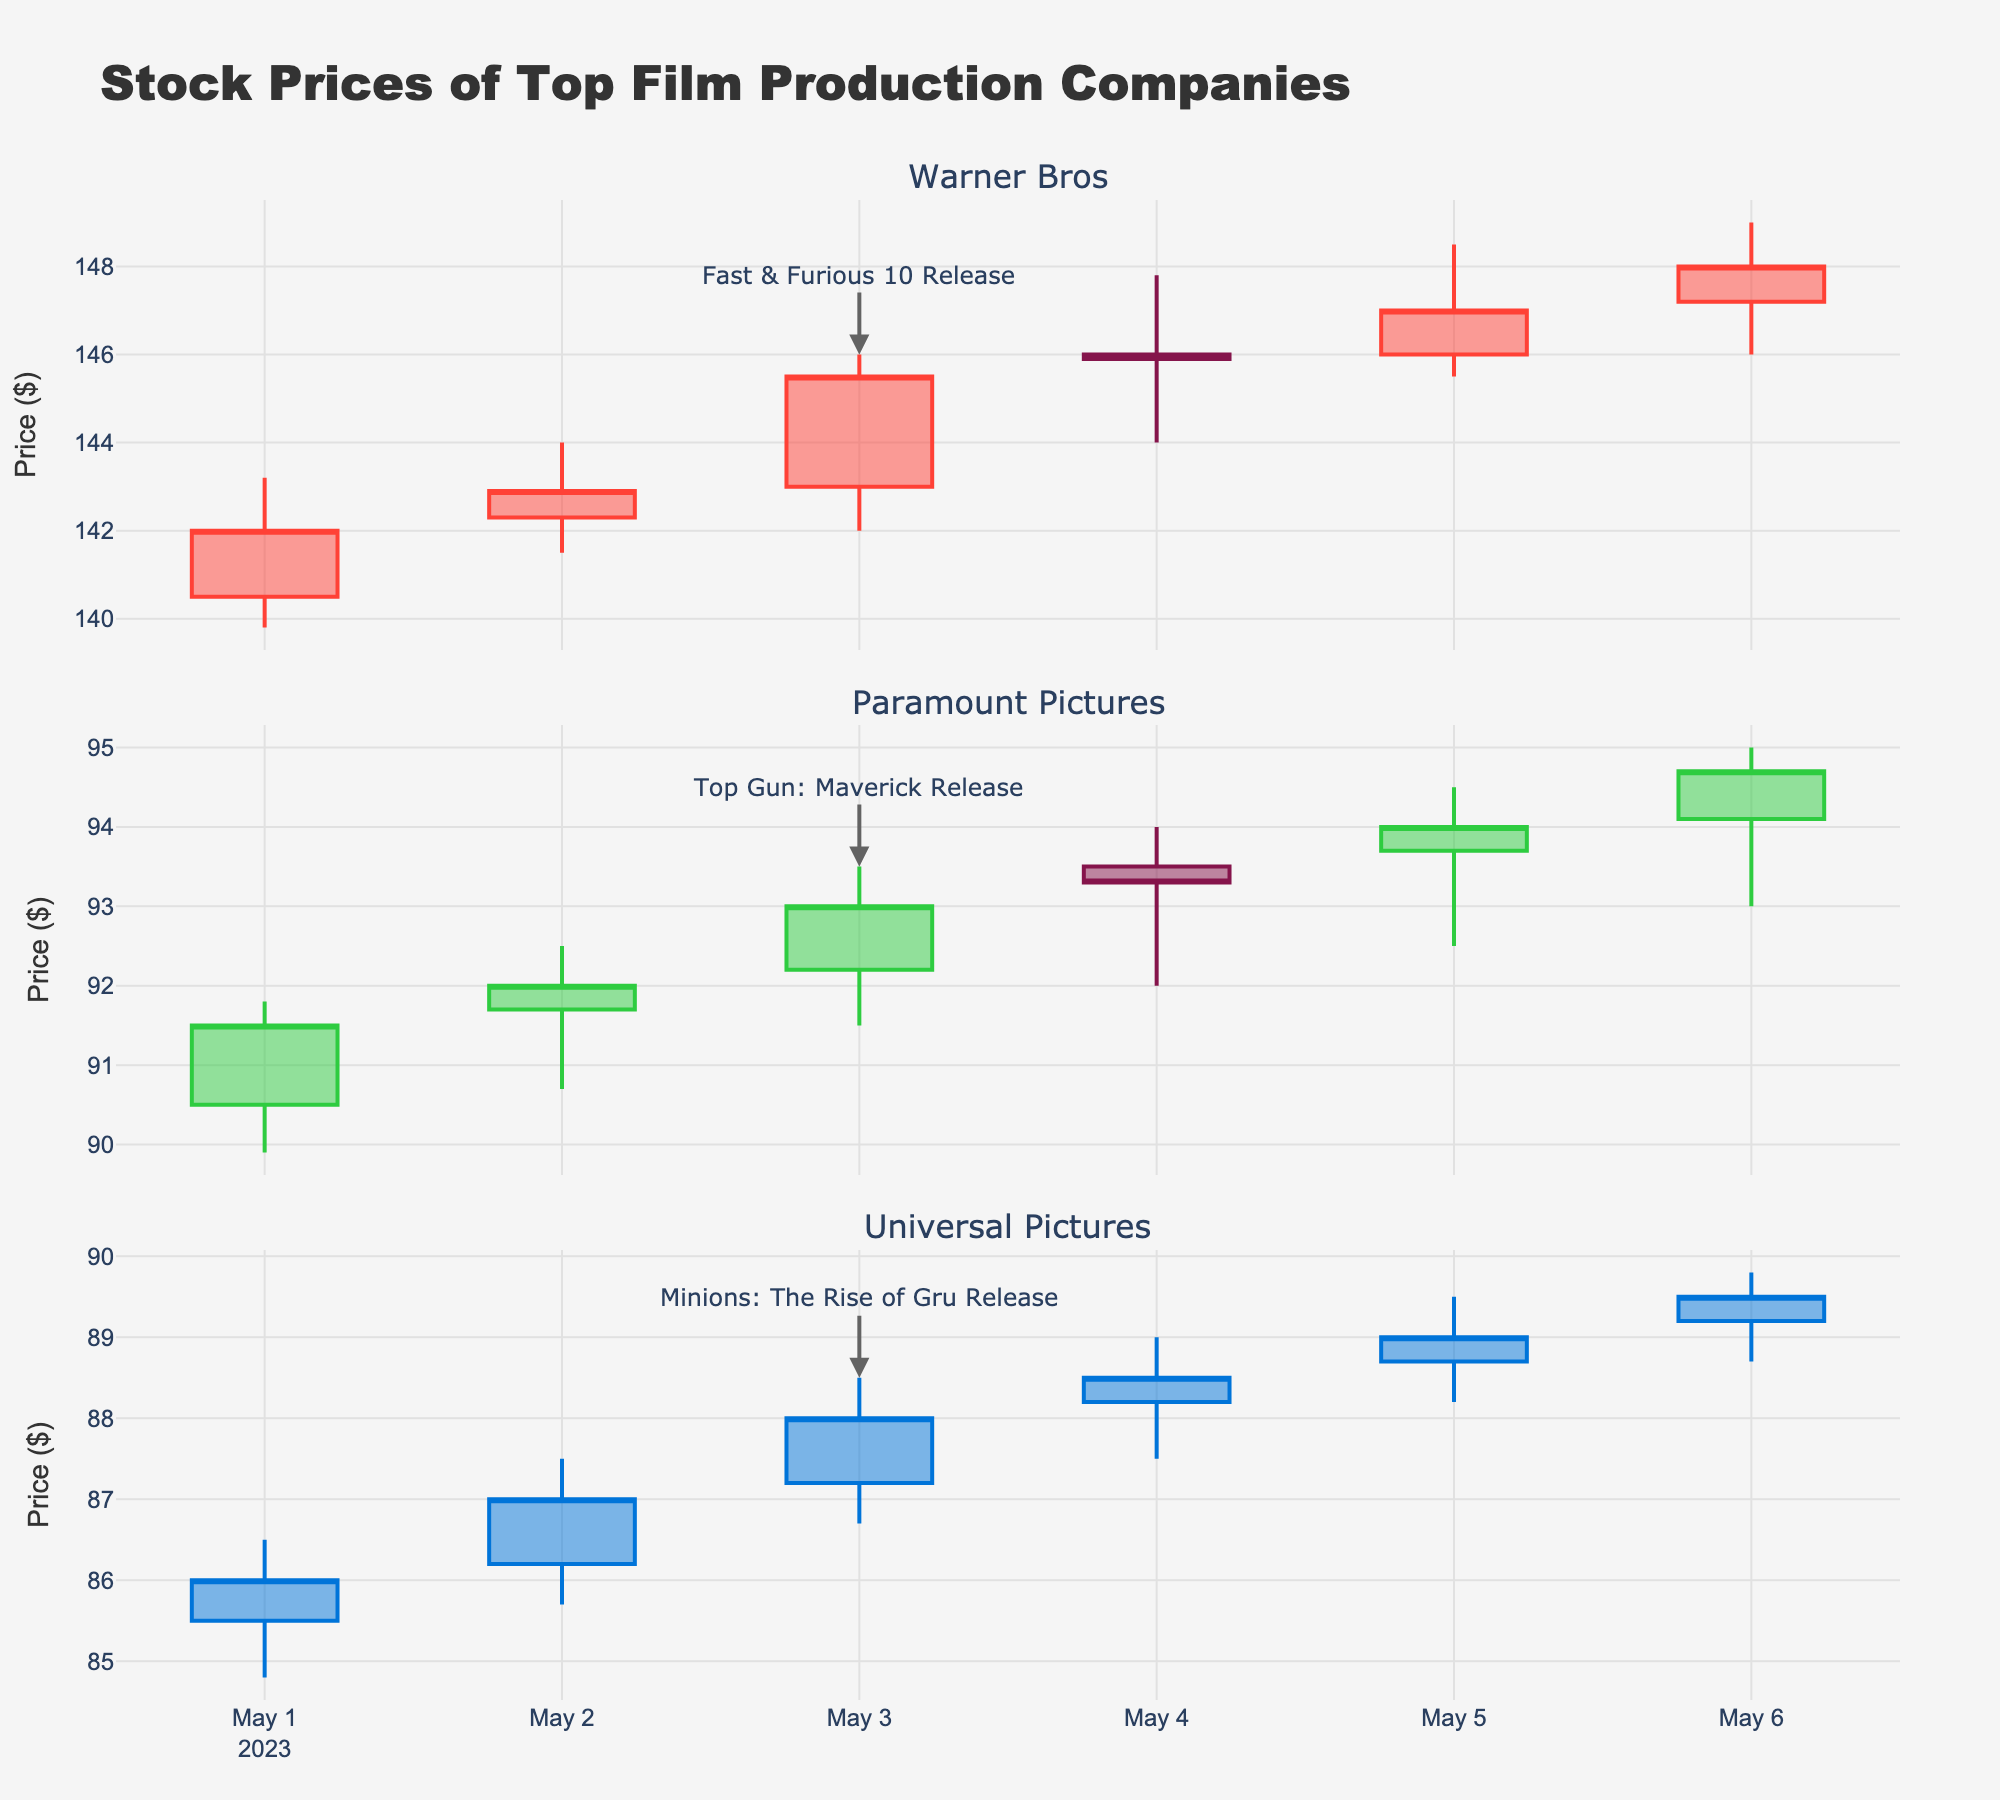Which company had a major movie release on May 3, 2023? By looking at the annotations on the plot, we see that May 3, 2023, has an annotation indicating a major movie release next to the candlesticks of three companies. Comparing the release date annotations, we find: Fast & Furious 10 for Warner Bros, Top Gun: Maverick for Paramount Pictures, and Minions: The Rise of Gru for Universal Pictures. Therefore, all three companies had major releases on May 3, 2023.
Answer: Warner Bros, Paramount Pictures, Universal Pictures What was the highest stock price for Warner Bros on May 5, 2023? By examining the candlestick for Warner Bros on May 5, 2023, we see that the highest point of the candlestick reaches $148.50
Answer: $148.50 How did the stock price of Universal Pictures change the day after the Minions: The Rise of Gru release? The Minions: The Rise of Gru was released on May 3, 2023. Comparing the closing prices of May 3 ($88.00) and May 4 ($88.50), Universal Pictures’ stock price increased.
Answer: Increased by $0.50 Which company had the highest trading volume on May 6, 2023? Looking at the volume bars on the plot, we see that Warner Bros had the highest trading volume on May 6, 2023, with 2,807,000 shares traded.
Answer: Warner Bros By how much did the stock price of Paramount Pictures increase from the open on May 1 to the close on May 6, 2023? The opening price of Paramount Pictures on May 1 was $90.50 and the closing price on May 6 was $94.70. The increase is $94.70 - $90.50 = $4.20.
Answer: $4.20 What was the trend in the stock price of Warner Bros after the release of Fast & Furious 10? Examining the candlesticks from May 3 to May 6, the stock prices of Warner Bros increased each day following the release of Fast & Furious 10 on May 3.
Answer: Upward trend Which company's stock price showed the most volatility on May 5, 2023? Stock price volatility can be observed by the candlestick length, emphasizing the range between high and low prices. On May 5, Universal Pictures displayed the longest candlestick, with a range from $89.50 to $88.20
Answer: Universal Pictures How does the trading volume change on the release day for Universal Pictures compared to the day before? The trading volume for Universal Pictures on May 2 was 1,705,000 shares, while on May 3, the volume was 1,806,000 shares. Therefore, it increased by 101,000 shares.
Answer: Increased by 101,000 shares 